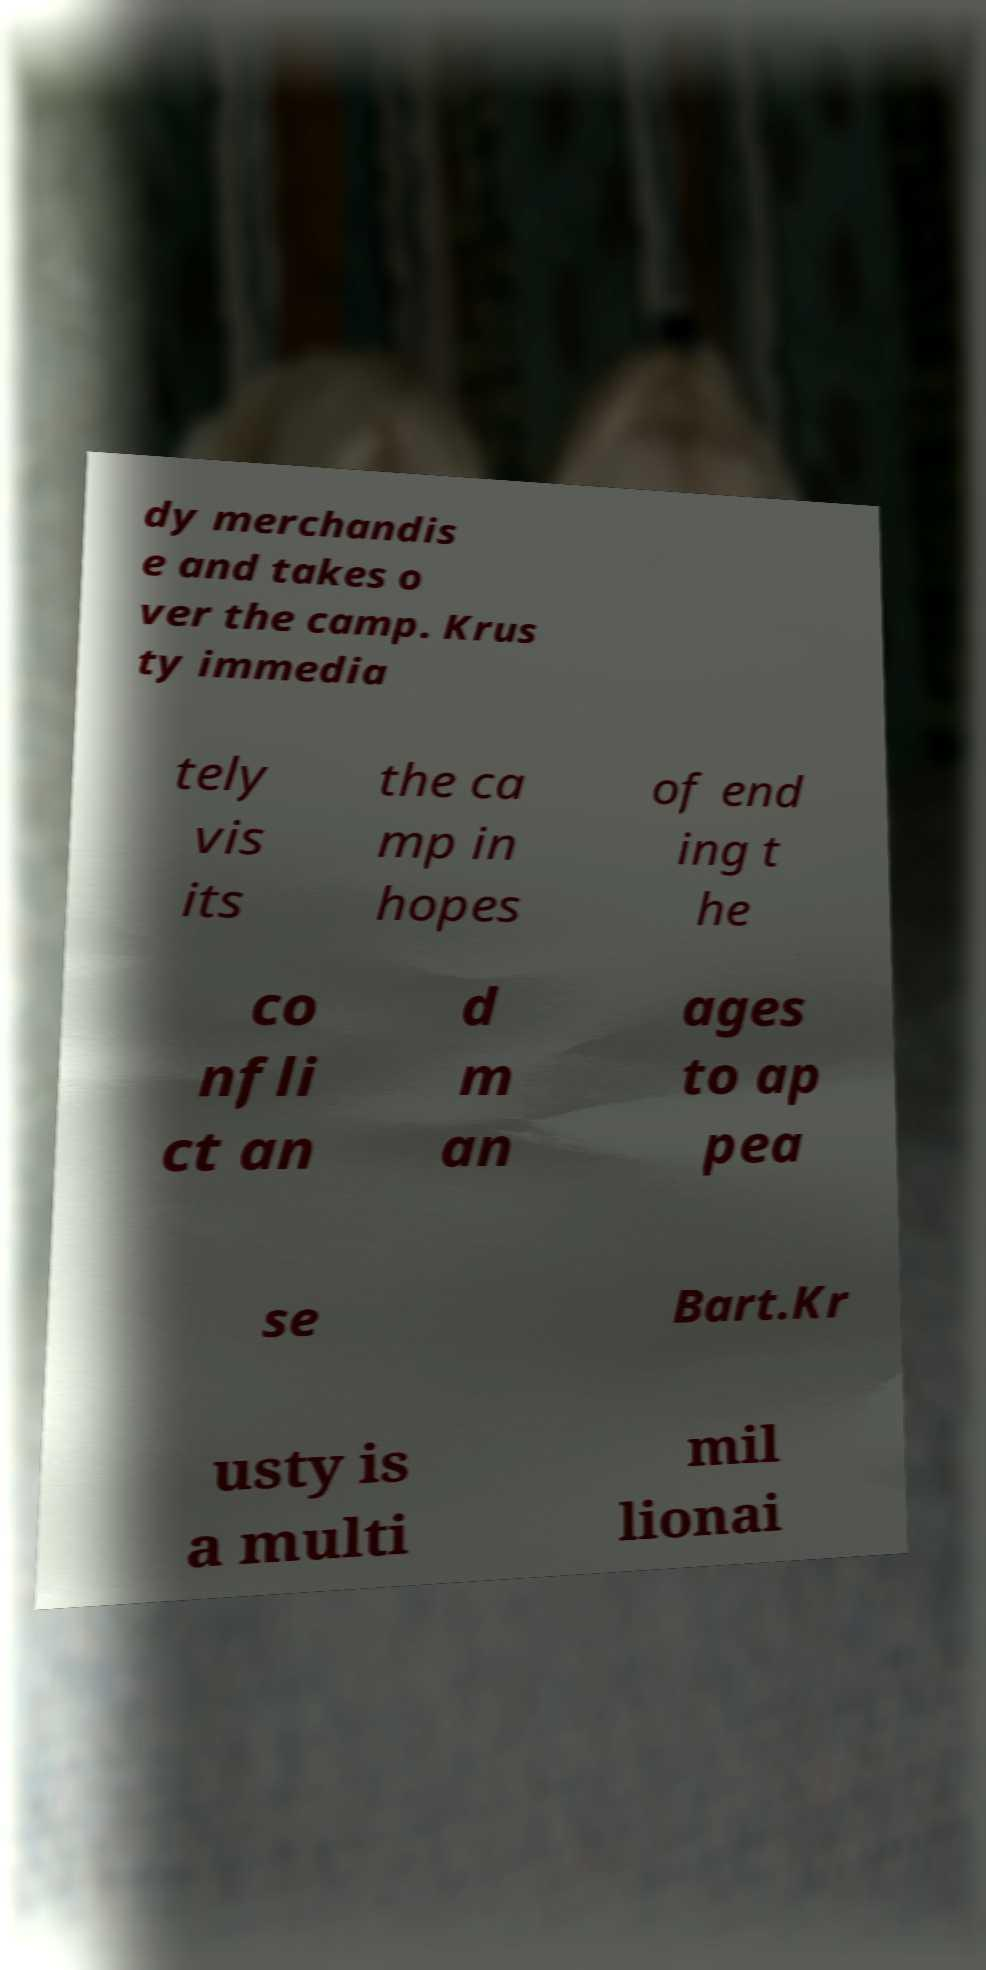For documentation purposes, I need the text within this image transcribed. Could you provide that? dy merchandis e and takes o ver the camp. Krus ty immedia tely vis its the ca mp in hopes of end ing t he co nfli ct an d m an ages to ap pea se Bart.Kr usty is a multi mil lionai 